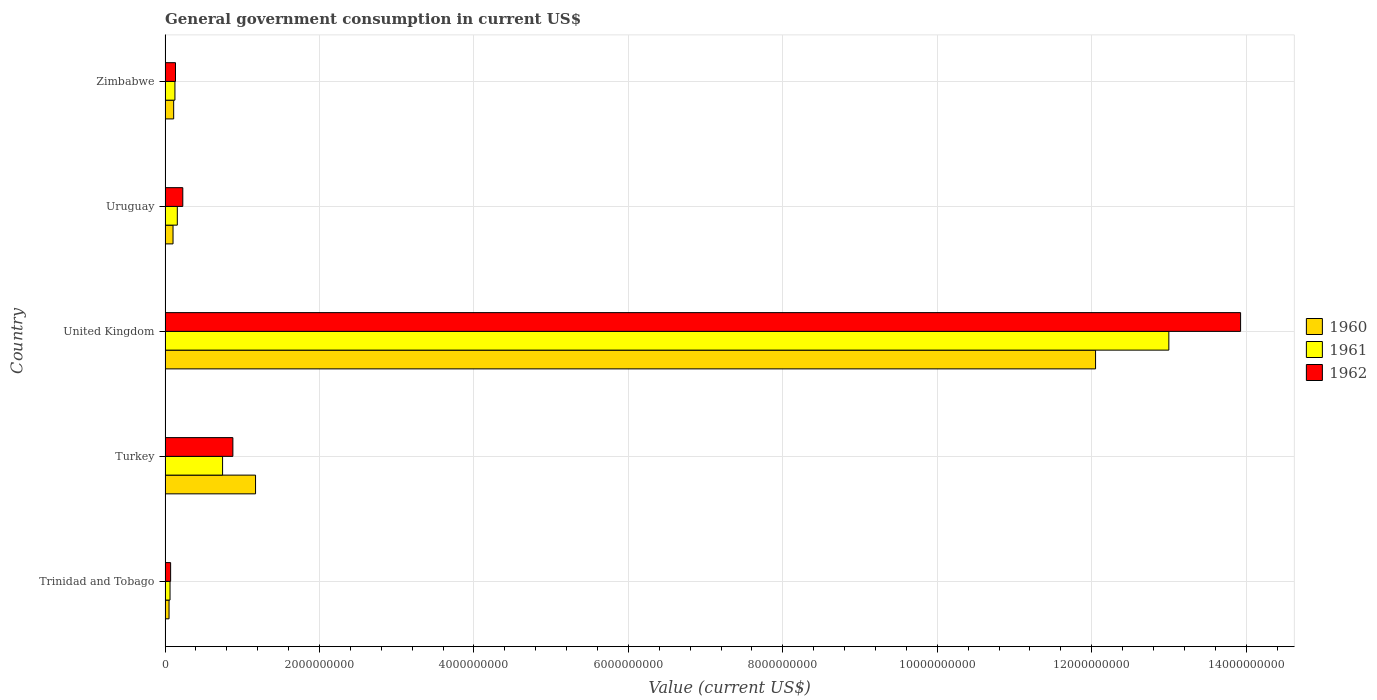How many different coloured bars are there?
Your answer should be compact. 3. How many groups of bars are there?
Give a very brief answer. 5. How many bars are there on the 1st tick from the top?
Provide a short and direct response. 3. How many bars are there on the 5th tick from the bottom?
Offer a terse response. 3. What is the label of the 2nd group of bars from the top?
Ensure brevity in your answer.  Uruguay. In how many cases, is the number of bars for a given country not equal to the number of legend labels?
Ensure brevity in your answer.  0. What is the government conusmption in 1961 in Trinidad and Tobago?
Give a very brief answer. 6.39e+07. Across all countries, what is the maximum government conusmption in 1960?
Your response must be concise. 1.20e+1. Across all countries, what is the minimum government conusmption in 1960?
Offer a terse response. 5.12e+07. In which country was the government conusmption in 1962 maximum?
Make the answer very short. United Kingdom. In which country was the government conusmption in 1960 minimum?
Your response must be concise. Trinidad and Tobago. What is the total government conusmption in 1962 in the graph?
Ensure brevity in your answer.  1.52e+1. What is the difference between the government conusmption in 1962 in Trinidad and Tobago and that in Zimbabwe?
Provide a short and direct response. -6.32e+07. What is the difference between the government conusmption in 1962 in Zimbabwe and the government conusmption in 1961 in United Kingdom?
Offer a terse response. -1.29e+1. What is the average government conusmption in 1962 per country?
Your answer should be very brief. 3.05e+09. What is the difference between the government conusmption in 1960 and government conusmption in 1961 in United Kingdom?
Your answer should be very brief. -9.49e+08. What is the ratio of the government conusmption in 1962 in Turkey to that in Zimbabwe?
Keep it short and to the point. 6.52. Is the difference between the government conusmption in 1960 in Uruguay and Zimbabwe greater than the difference between the government conusmption in 1961 in Uruguay and Zimbabwe?
Provide a short and direct response. No. What is the difference between the highest and the second highest government conusmption in 1961?
Your response must be concise. 1.23e+1. What is the difference between the highest and the lowest government conusmption in 1962?
Provide a short and direct response. 1.39e+1. How many bars are there?
Offer a terse response. 15. Are all the bars in the graph horizontal?
Your answer should be very brief. Yes. What is the difference between two consecutive major ticks on the X-axis?
Your answer should be very brief. 2.00e+09. Does the graph contain any zero values?
Your answer should be compact. No. Does the graph contain grids?
Provide a short and direct response. Yes. Where does the legend appear in the graph?
Provide a short and direct response. Center right. How many legend labels are there?
Provide a succinct answer. 3. How are the legend labels stacked?
Keep it short and to the point. Vertical. What is the title of the graph?
Your response must be concise. General government consumption in current US$. Does "1991" appear as one of the legend labels in the graph?
Offer a terse response. No. What is the label or title of the X-axis?
Ensure brevity in your answer.  Value (current US$). What is the Value (current US$) in 1960 in Trinidad and Tobago?
Ensure brevity in your answer.  5.12e+07. What is the Value (current US$) in 1961 in Trinidad and Tobago?
Keep it short and to the point. 6.39e+07. What is the Value (current US$) in 1962 in Trinidad and Tobago?
Your response must be concise. 7.16e+07. What is the Value (current US$) of 1960 in Turkey?
Ensure brevity in your answer.  1.17e+09. What is the Value (current US$) of 1961 in Turkey?
Make the answer very short. 7.44e+08. What is the Value (current US$) of 1962 in Turkey?
Give a very brief answer. 8.78e+08. What is the Value (current US$) of 1960 in United Kingdom?
Ensure brevity in your answer.  1.20e+1. What is the Value (current US$) of 1961 in United Kingdom?
Your response must be concise. 1.30e+1. What is the Value (current US$) in 1962 in United Kingdom?
Provide a short and direct response. 1.39e+1. What is the Value (current US$) of 1960 in Uruguay?
Ensure brevity in your answer.  1.03e+08. What is the Value (current US$) of 1961 in Uruguay?
Your response must be concise. 1.58e+08. What is the Value (current US$) in 1962 in Uruguay?
Make the answer very short. 2.29e+08. What is the Value (current US$) in 1960 in Zimbabwe?
Keep it short and to the point. 1.11e+08. What is the Value (current US$) in 1961 in Zimbabwe?
Provide a short and direct response. 1.27e+08. What is the Value (current US$) in 1962 in Zimbabwe?
Make the answer very short. 1.35e+08. Across all countries, what is the maximum Value (current US$) in 1960?
Keep it short and to the point. 1.20e+1. Across all countries, what is the maximum Value (current US$) in 1961?
Provide a succinct answer. 1.30e+1. Across all countries, what is the maximum Value (current US$) in 1962?
Ensure brevity in your answer.  1.39e+1. Across all countries, what is the minimum Value (current US$) of 1960?
Provide a succinct answer. 5.12e+07. Across all countries, what is the minimum Value (current US$) of 1961?
Offer a very short reply. 6.39e+07. Across all countries, what is the minimum Value (current US$) of 1962?
Keep it short and to the point. 7.16e+07. What is the total Value (current US$) in 1960 in the graph?
Your answer should be very brief. 1.35e+1. What is the total Value (current US$) in 1961 in the graph?
Ensure brevity in your answer.  1.41e+1. What is the total Value (current US$) in 1962 in the graph?
Provide a short and direct response. 1.52e+1. What is the difference between the Value (current US$) in 1960 in Trinidad and Tobago and that in Turkey?
Provide a short and direct response. -1.12e+09. What is the difference between the Value (current US$) of 1961 in Trinidad and Tobago and that in Turkey?
Make the answer very short. -6.81e+08. What is the difference between the Value (current US$) in 1962 in Trinidad and Tobago and that in Turkey?
Ensure brevity in your answer.  -8.06e+08. What is the difference between the Value (current US$) of 1960 in Trinidad and Tobago and that in United Kingdom?
Your answer should be compact. -1.20e+1. What is the difference between the Value (current US$) in 1961 in Trinidad and Tobago and that in United Kingdom?
Keep it short and to the point. -1.29e+1. What is the difference between the Value (current US$) of 1962 in Trinidad and Tobago and that in United Kingdom?
Your response must be concise. -1.39e+1. What is the difference between the Value (current US$) in 1960 in Trinidad and Tobago and that in Uruguay?
Your answer should be very brief. -5.16e+07. What is the difference between the Value (current US$) of 1961 in Trinidad and Tobago and that in Uruguay?
Your response must be concise. -9.44e+07. What is the difference between the Value (current US$) of 1962 in Trinidad and Tobago and that in Uruguay?
Keep it short and to the point. -1.58e+08. What is the difference between the Value (current US$) in 1960 in Trinidad and Tobago and that in Zimbabwe?
Provide a succinct answer. -5.99e+07. What is the difference between the Value (current US$) in 1961 in Trinidad and Tobago and that in Zimbabwe?
Give a very brief answer. -6.35e+07. What is the difference between the Value (current US$) in 1962 in Trinidad and Tobago and that in Zimbabwe?
Ensure brevity in your answer.  -6.32e+07. What is the difference between the Value (current US$) in 1960 in Turkey and that in United Kingdom?
Offer a terse response. -1.09e+1. What is the difference between the Value (current US$) in 1961 in Turkey and that in United Kingdom?
Give a very brief answer. -1.23e+1. What is the difference between the Value (current US$) of 1962 in Turkey and that in United Kingdom?
Give a very brief answer. -1.30e+1. What is the difference between the Value (current US$) of 1960 in Turkey and that in Uruguay?
Keep it short and to the point. 1.07e+09. What is the difference between the Value (current US$) in 1961 in Turkey and that in Uruguay?
Ensure brevity in your answer.  5.86e+08. What is the difference between the Value (current US$) of 1962 in Turkey and that in Uruguay?
Make the answer very short. 6.49e+08. What is the difference between the Value (current US$) of 1960 in Turkey and that in Zimbabwe?
Offer a terse response. 1.06e+09. What is the difference between the Value (current US$) of 1961 in Turkey and that in Zimbabwe?
Your answer should be compact. 6.17e+08. What is the difference between the Value (current US$) in 1962 in Turkey and that in Zimbabwe?
Provide a succinct answer. 7.43e+08. What is the difference between the Value (current US$) in 1960 in United Kingdom and that in Uruguay?
Provide a succinct answer. 1.19e+1. What is the difference between the Value (current US$) in 1961 in United Kingdom and that in Uruguay?
Your response must be concise. 1.28e+1. What is the difference between the Value (current US$) of 1962 in United Kingdom and that in Uruguay?
Your answer should be very brief. 1.37e+1. What is the difference between the Value (current US$) in 1960 in United Kingdom and that in Zimbabwe?
Provide a succinct answer. 1.19e+1. What is the difference between the Value (current US$) of 1961 in United Kingdom and that in Zimbabwe?
Provide a short and direct response. 1.29e+1. What is the difference between the Value (current US$) of 1962 in United Kingdom and that in Zimbabwe?
Provide a short and direct response. 1.38e+1. What is the difference between the Value (current US$) of 1960 in Uruguay and that in Zimbabwe?
Provide a succinct answer. -8.26e+06. What is the difference between the Value (current US$) in 1961 in Uruguay and that in Zimbabwe?
Your response must be concise. 3.09e+07. What is the difference between the Value (current US$) of 1962 in Uruguay and that in Zimbabwe?
Your response must be concise. 9.44e+07. What is the difference between the Value (current US$) of 1960 in Trinidad and Tobago and the Value (current US$) of 1961 in Turkey?
Your response must be concise. -6.93e+08. What is the difference between the Value (current US$) in 1960 in Trinidad and Tobago and the Value (current US$) in 1962 in Turkey?
Offer a very short reply. -8.27e+08. What is the difference between the Value (current US$) of 1961 in Trinidad and Tobago and the Value (current US$) of 1962 in Turkey?
Offer a very short reply. -8.14e+08. What is the difference between the Value (current US$) of 1960 in Trinidad and Tobago and the Value (current US$) of 1961 in United Kingdom?
Make the answer very short. -1.29e+1. What is the difference between the Value (current US$) in 1960 in Trinidad and Tobago and the Value (current US$) in 1962 in United Kingdom?
Ensure brevity in your answer.  -1.39e+1. What is the difference between the Value (current US$) in 1961 in Trinidad and Tobago and the Value (current US$) in 1962 in United Kingdom?
Offer a terse response. -1.39e+1. What is the difference between the Value (current US$) in 1960 in Trinidad and Tobago and the Value (current US$) in 1961 in Uruguay?
Keep it short and to the point. -1.07e+08. What is the difference between the Value (current US$) of 1960 in Trinidad and Tobago and the Value (current US$) of 1962 in Uruguay?
Your answer should be compact. -1.78e+08. What is the difference between the Value (current US$) in 1961 in Trinidad and Tobago and the Value (current US$) in 1962 in Uruguay?
Provide a succinct answer. -1.65e+08. What is the difference between the Value (current US$) in 1960 in Trinidad and Tobago and the Value (current US$) in 1961 in Zimbabwe?
Your response must be concise. -7.61e+07. What is the difference between the Value (current US$) of 1960 in Trinidad and Tobago and the Value (current US$) of 1962 in Zimbabwe?
Make the answer very short. -8.35e+07. What is the difference between the Value (current US$) in 1961 in Trinidad and Tobago and the Value (current US$) in 1962 in Zimbabwe?
Provide a short and direct response. -7.09e+07. What is the difference between the Value (current US$) in 1960 in Turkey and the Value (current US$) in 1961 in United Kingdom?
Your response must be concise. -1.18e+1. What is the difference between the Value (current US$) in 1960 in Turkey and the Value (current US$) in 1962 in United Kingdom?
Give a very brief answer. -1.28e+1. What is the difference between the Value (current US$) of 1961 in Turkey and the Value (current US$) of 1962 in United Kingdom?
Your answer should be very brief. -1.32e+1. What is the difference between the Value (current US$) in 1960 in Turkey and the Value (current US$) in 1961 in Uruguay?
Give a very brief answer. 1.01e+09. What is the difference between the Value (current US$) of 1960 in Turkey and the Value (current US$) of 1962 in Uruguay?
Offer a terse response. 9.42e+08. What is the difference between the Value (current US$) in 1961 in Turkey and the Value (current US$) in 1962 in Uruguay?
Make the answer very short. 5.15e+08. What is the difference between the Value (current US$) of 1960 in Turkey and the Value (current US$) of 1961 in Zimbabwe?
Your answer should be very brief. 1.04e+09. What is the difference between the Value (current US$) in 1960 in Turkey and the Value (current US$) in 1962 in Zimbabwe?
Make the answer very short. 1.04e+09. What is the difference between the Value (current US$) in 1961 in Turkey and the Value (current US$) in 1962 in Zimbabwe?
Make the answer very short. 6.10e+08. What is the difference between the Value (current US$) of 1960 in United Kingdom and the Value (current US$) of 1961 in Uruguay?
Provide a succinct answer. 1.19e+1. What is the difference between the Value (current US$) of 1960 in United Kingdom and the Value (current US$) of 1962 in Uruguay?
Provide a short and direct response. 1.18e+1. What is the difference between the Value (current US$) in 1961 in United Kingdom and the Value (current US$) in 1962 in Uruguay?
Your answer should be very brief. 1.28e+1. What is the difference between the Value (current US$) in 1960 in United Kingdom and the Value (current US$) in 1961 in Zimbabwe?
Your response must be concise. 1.19e+1. What is the difference between the Value (current US$) of 1960 in United Kingdom and the Value (current US$) of 1962 in Zimbabwe?
Offer a very short reply. 1.19e+1. What is the difference between the Value (current US$) of 1961 in United Kingdom and the Value (current US$) of 1962 in Zimbabwe?
Provide a succinct answer. 1.29e+1. What is the difference between the Value (current US$) in 1960 in Uruguay and the Value (current US$) in 1961 in Zimbabwe?
Your answer should be very brief. -2.45e+07. What is the difference between the Value (current US$) of 1960 in Uruguay and the Value (current US$) of 1962 in Zimbabwe?
Ensure brevity in your answer.  -3.19e+07. What is the difference between the Value (current US$) in 1961 in Uruguay and the Value (current US$) in 1962 in Zimbabwe?
Provide a succinct answer. 2.35e+07. What is the average Value (current US$) in 1960 per country?
Keep it short and to the point. 2.70e+09. What is the average Value (current US$) in 1961 per country?
Keep it short and to the point. 2.82e+09. What is the average Value (current US$) in 1962 per country?
Your answer should be compact. 3.05e+09. What is the difference between the Value (current US$) in 1960 and Value (current US$) in 1961 in Trinidad and Tobago?
Make the answer very short. -1.27e+07. What is the difference between the Value (current US$) in 1960 and Value (current US$) in 1962 in Trinidad and Tobago?
Provide a succinct answer. -2.04e+07. What is the difference between the Value (current US$) in 1961 and Value (current US$) in 1962 in Trinidad and Tobago?
Give a very brief answer. -7.70e+06. What is the difference between the Value (current US$) in 1960 and Value (current US$) in 1961 in Turkey?
Your answer should be very brief. 4.27e+08. What is the difference between the Value (current US$) in 1960 and Value (current US$) in 1962 in Turkey?
Keep it short and to the point. 2.94e+08. What is the difference between the Value (current US$) of 1961 and Value (current US$) of 1962 in Turkey?
Give a very brief answer. -1.33e+08. What is the difference between the Value (current US$) of 1960 and Value (current US$) of 1961 in United Kingdom?
Give a very brief answer. -9.49e+08. What is the difference between the Value (current US$) of 1960 and Value (current US$) of 1962 in United Kingdom?
Give a very brief answer. -1.88e+09. What is the difference between the Value (current US$) in 1961 and Value (current US$) in 1962 in United Kingdom?
Your answer should be compact. -9.29e+08. What is the difference between the Value (current US$) in 1960 and Value (current US$) in 1961 in Uruguay?
Give a very brief answer. -5.54e+07. What is the difference between the Value (current US$) in 1960 and Value (current US$) in 1962 in Uruguay?
Offer a terse response. -1.26e+08. What is the difference between the Value (current US$) of 1961 and Value (current US$) of 1962 in Uruguay?
Your response must be concise. -7.09e+07. What is the difference between the Value (current US$) in 1960 and Value (current US$) in 1961 in Zimbabwe?
Keep it short and to the point. -1.63e+07. What is the difference between the Value (current US$) in 1960 and Value (current US$) in 1962 in Zimbabwe?
Provide a short and direct response. -2.37e+07. What is the difference between the Value (current US$) of 1961 and Value (current US$) of 1962 in Zimbabwe?
Keep it short and to the point. -7.39e+06. What is the ratio of the Value (current US$) in 1960 in Trinidad and Tobago to that in Turkey?
Provide a succinct answer. 0.04. What is the ratio of the Value (current US$) of 1961 in Trinidad and Tobago to that in Turkey?
Provide a short and direct response. 0.09. What is the ratio of the Value (current US$) of 1962 in Trinidad and Tobago to that in Turkey?
Keep it short and to the point. 0.08. What is the ratio of the Value (current US$) in 1960 in Trinidad and Tobago to that in United Kingdom?
Offer a very short reply. 0. What is the ratio of the Value (current US$) of 1961 in Trinidad and Tobago to that in United Kingdom?
Keep it short and to the point. 0. What is the ratio of the Value (current US$) in 1962 in Trinidad and Tobago to that in United Kingdom?
Keep it short and to the point. 0.01. What is the ratio of the Value (current US$) of 1960 in Trinidad and Tobago to that in Uruguay?
Ensure brevity in your answer.  0.5. What is the ratio of the Value (current US$) of 1961 in Trinidad and Tobago to that in Uruguay?
Keep it short and to the point. 0.4. What is the ratio of the Value (current US$) in 1962 in Trinidad and Tobago to that in Uruguay?
Provide a succinct answer. 0.31. What is the ratio of the Value (current US$) in 1960 in Trinidad and Tobago to that in Zimbabwe?
Offer a terse response. 0.46. What is the ratio of the Value (current US$) in 1961 in Trinidad and Tobago to that in Zimbabwe?
Your response must be concise. 0.5. What is the ratio of the Value (current US$) of 1962 in Trinidad and Tobago to that in Zimbabwe?
Offer a very short reply. 0.53. What is the ratio of the Value (current US$) in 1960 in Turkey to that in United Kingdom?
Give a very brief answer. 0.1. What is the ratio of the Value (current US$) in 1961 in Turkey to that in United Kingdom?
Your answer should be compact. 0.06. What is the ratio of the Value (current US$) in 1962 in Turkey to that in United Kingdom?
Make the answer very short. 0.06. What is the ratio of the Value (current US$) in 1960 in Turkey to that in Uruguay?
Provide a succinct answer. 11.39. What is the ratio of the Value (current US$) in 1961 in Turkey to that in Uruguay?
Offer a terse response. 4.7. What is the ratio of the Value (current US$) in 1962 in Turkey to that in Uruguay?
Offer a very short reply. 3.83. What is the ratio of the Value (current US$) in 1960 in Turkey to that in Zimbabwe?
Provide a succinct answer. 10.55. What is the ratio of the Value (current US$) of 1961 in Turkey to that in Zimbabwe?
Offer a terse response. 5.85. What is the ratio of the Value (current US$) in 1962 in Turkey to that in Zimbabwe?
Offer a terse response. 6.52. What is the ratio of the Value (current US$) in 1960 in United Kingdom to that in Uruguay?
Your response must be concise. 117.2. What is the ratio of the Value (current US$) in 1961 in United Kingdom to that in Uruguay?
Ensure brevity in your answer.  82.14. What is the ratio of the Value (current US$) of 1962 in United Kingdom to that in Uruguay?
Your response must be concise. 60.77. What is the ratio of the Value (current US$) in 1960 in United Kingdom to that in Zimbabwe?
Your answer should be compact. 108.49. What is the ratio of the Value (current US$) in 1961 in United Kingdom to that in Zimbabwe?
Your answer should be compact. 102.08. What is the ratio of the Value (current US$) of 1962 in United Kingdom to that in Zimbabwe?
Give a very brief answer. 103.37. What is the ratio of the Value (current US$) in 1960 in Uruguay to that in Zimbabwe?
Provide a short and direct response. 0.93. What is the ratio of the Value (current US$) of 1961 in Uruguay to that in Zimbabwe?
Offer a terse response. 1.24. What is the ratio of the Value (current US$) of 1962 in Uruguay to that in Zimbabwe?
Offer a very short reply. 1.7. What is the difference between the highest and the second highest Value (current US$) of 1960?
Provide a short and direct response. 1.09e+1. What is the difference between the highest and the second highest Value (current US$) in 1961?
Offer a very short reply. 1.23e+1. What is the difference between the highest and the second highest Value (current US$) of 1962?
Offer a terse response. 1.30e+1. What is the difference between the highest and the lowest Value (current US$) of 1960?
Your response must be concise. 1.20e+1. What is the difference between the highest and the lowest Value (current US$) in 1961?
Your answer should be very brief. 1.29e+1. What is the difference between the highest and the lowest Value (current US$) in 1962?
Provide a succinct answer. 1.39e+1. 